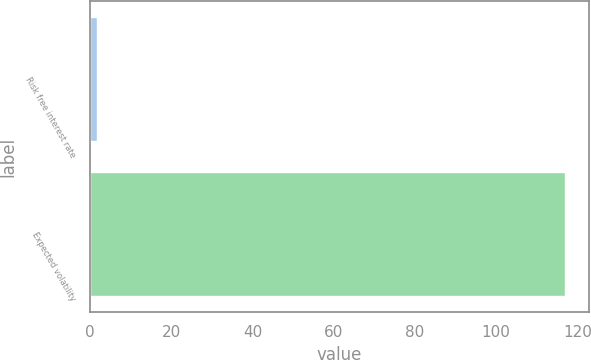<chart> <loc_0><loc_0><loc_500><loc_500><bar_chart><fcel>Risk free interest rate<fcel>Expected volatility<nl><fcel>1.73<fcel>117<nl></chart> 